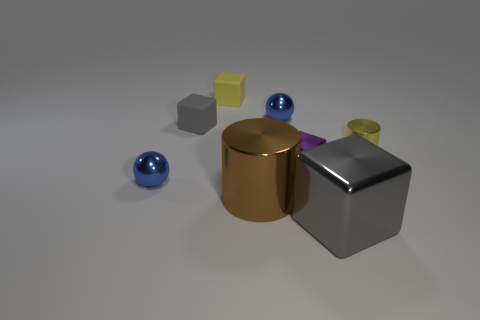Do the small purple shiny thing and the yellow metal object have the same shape?
Your response must be concise. No. Is there anything else that has the same shape as the gray rubber thing?
Your answer should be compact. Yes. Is there a tiny blue rubber cylinder?
Make the answer very short. No. There is a gray rubber object; does it have the same shape as the gray object on the right side of the yellow rubber thing?
Provide a succinct answer. Yes. What material is the small yellow block behind the gray block behind the large gray metallic thing made of?
Offer a terse response. Rubber. What is the color of the big cylinder?
Give a very brief answer. Brown. There is a small sphere that is behind the tiny cylinder; is its color the same as the small shiny thing on the left side of the large cylinder?
Your answer should be compact. Yes. There is another metallic object that is the same shape as the large gray thing; what size is it?
Offer a terse response. Small. Are there any small cylinders of the same color as the big metallic cylinder?
Provide a succinct answer. No. What material is the small cube that is the same color as the large block?
Your answer should be compact. Rubber. 